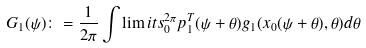Convert formula to latex. <formula><loc_0><loc_0><loc_500><loc_500>G _ { 1 } ( \psi ) \colon = \frac { 1 } { 2 \pi } \int \lim i t s _ { 0 } ^ { 2 \pi } p _ { 1 } ^ { T } ( \psi + \theta ) g _ { 1 } ( x _ { 0 } ( \psi + \theta ) , \theta ) d \theta</formula> 